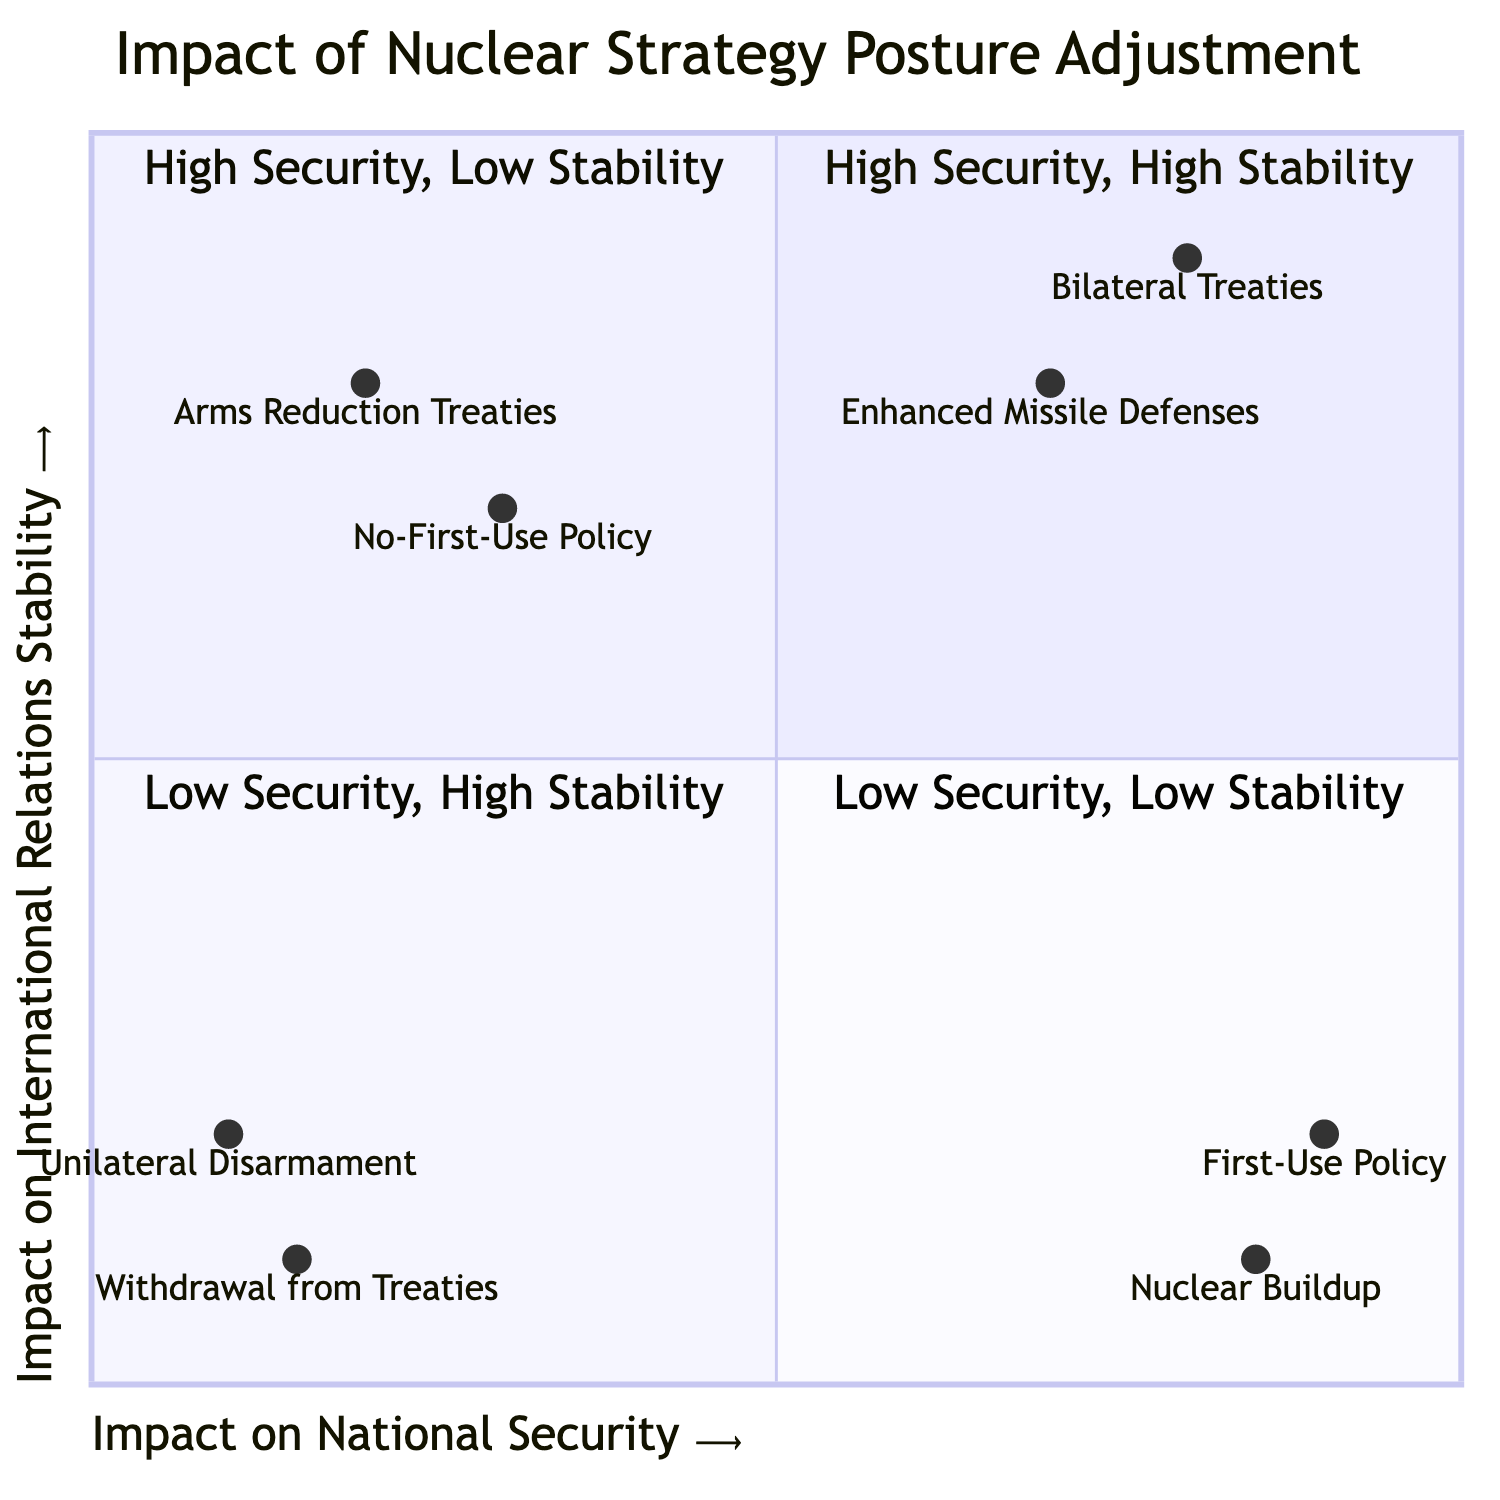What is the element in the High Security, High Stability quadrant? The High Security, High Stability quadrant contains two elements: Enhanced Missile Defenses and Bilateral Treaties. Both contribute positively to national security and international relations stability.
Answer: Enhanced Missile Defenses, Bilateral Treaties What is the impact on national security for the First-Use Policy? The First-Use Policy has an impact value of 0.9 on the national security axis, indicating a strong improvement in national security.
Answer: 0.9 Which element has the lowest impact on international relations stability? The element with the lowest impact on international relations stability is Withdrawal from Treaties, which has a value of 0.1 in this category.
Answer: Withdrawal from Treaties How many elements are in the Low Security, Low Stability quadrant? There are two elements in the Low Security, Low Stability quadrant: Unilateral Disarmament and Withdrawal from Treaties. This corresponds to the specified quadrant characteristics.
Answer: 2 Which strategy combines low security with high stability? The No-First-Use Policy is a strategy that combines low security with high stability, having a low impact on national security (0.3) but a higher impact on international relations stability (0.7).
Answer: No-First-Use Policy What is the relationship between Nuclear Buildup and international relations stability? Nuclear Buildup has a direct negative relationship with international relations stability as it has a value of 0.1 on that axis, indicating it destabilizes international relations despite improving national security.
Answer: 0.1 Which element indicates a commitment to reducing nuclear arms? Arms Reduction Treaties indicate a commitment to reducing nuclear arms, showing an impact of 0.2 on national security and 0.8 on international relations stability.
Answer: Arms Reduction Treaties In which quadrant does the Enhanced Missile Defenses fall? The Enhanced Missile Defenses element falls within the High Security, High Stability quadrant as it scores high in both national security and international relations stability.
Answer: High Security, High Stability What is the impact on national security for Unilateral Disarmament? The impact on national security for Unilateral Disarmament is 0.1, indicating a significant decrease in national security.
Answer: 0.1 